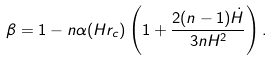Convert formula to latex. <formula><loc_0><loc_0><loc_500><loc_500>\beta = 1 - n \alpha ( H r _ { c } ) \left ( 1 + \frac { 2 ( n - 1 ) \dot { H } } { 3 n H ^ { 2 } } \right ) .</formula> 